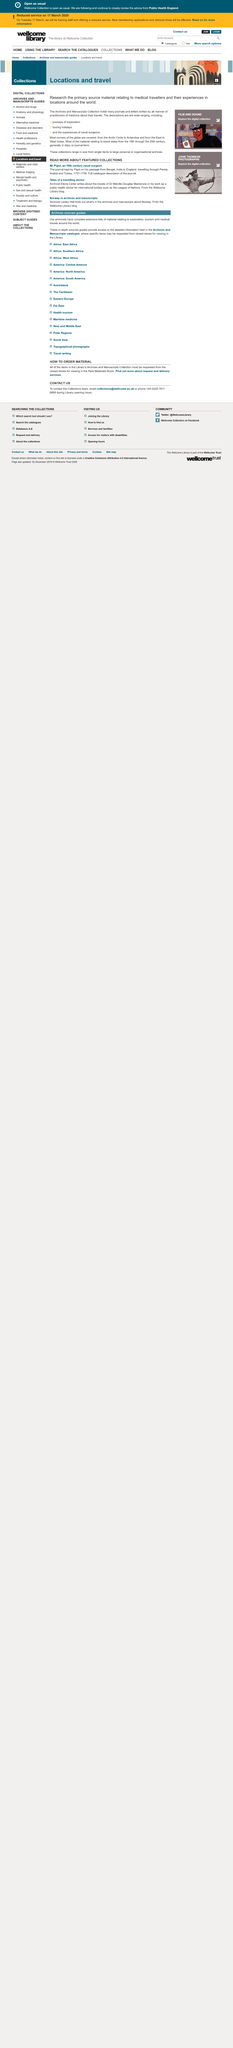Specify some key components in this picture. Dr. Melville Douglas Mackenzie was a public health doctor who was involved in various international bodies, such as the League of Nations, where he worked on important public health projects. The writer, Elena Carter, wrote about a travelling doctor named Dr. Melville Douglas Mackenzie. Mr. Pigot, an 18th century naval surgeon, kept a journal from 1757 to 1759. 